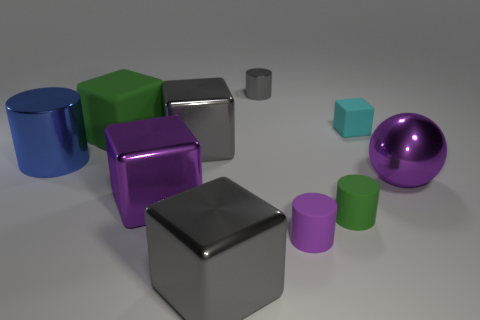What is the material of the cylinder that is the same color as the sphere?
Keep it short and to the point. Rubber. Is the gray object that is in front of the big blue shiny thing made of the same material as the purple thing left of the gray cylinder?
Your response must be concise. Yes. The green object in front of the cylinder that is to the left of the gray cube behind the blue shiny thing is what shape?
Your answer should be compact. Cylinder. What is the shape of the blue object?
Make the answer very short. Cylinder. What shape is the rubber object that is the same size as the blue metallic object?
Make the answer very short. Cube. How many other objects are there of the same color as the big metal sphere?
Your answer should be compact. 2. There is a purple object that is to the left of the tiny purple thing; does it have the same shape as the metallic thing to the left of the large green matte thing?
Make the answer very short. No. How many objects are either gray shiny things behind the large green cube or big things that are to the right of the green rubber cube?
Your answer should be compact. 5. How many other things are the same material as the ball?
Make the answer very short. 5. Is the material of the thing that is to the left of the big green rubber block the same as the green cylinder?
Your answer should be compact. No. 